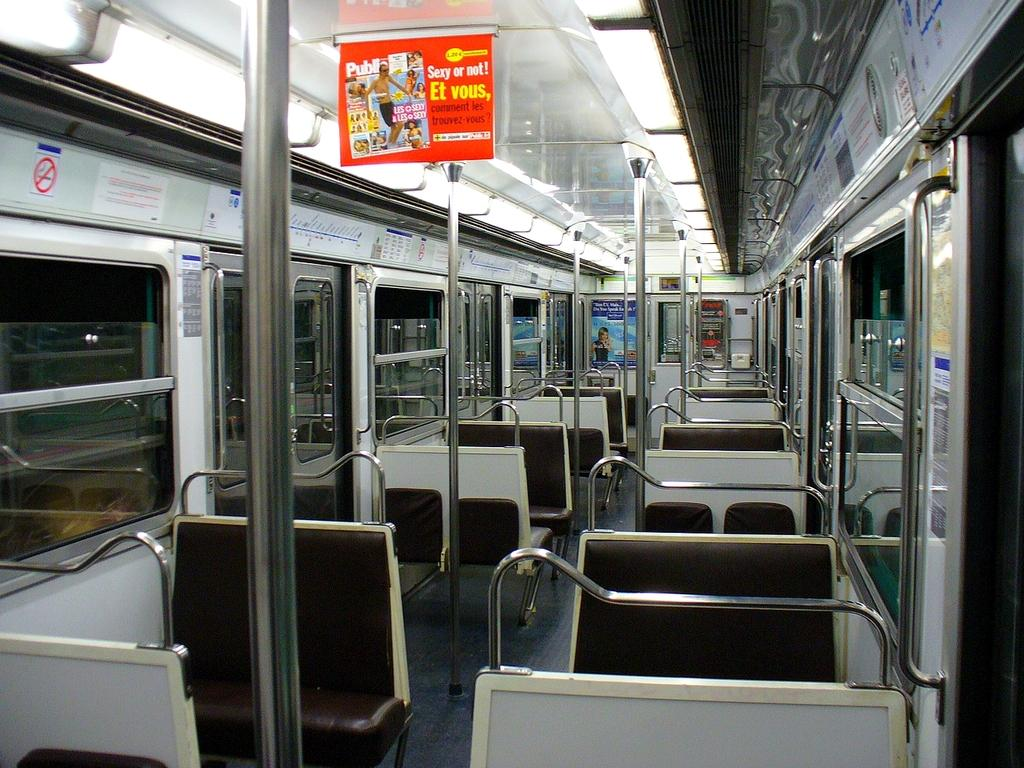<image>
Summarize the visual content of the image. a bus has a flag with an ad on it saying Sexy or not 